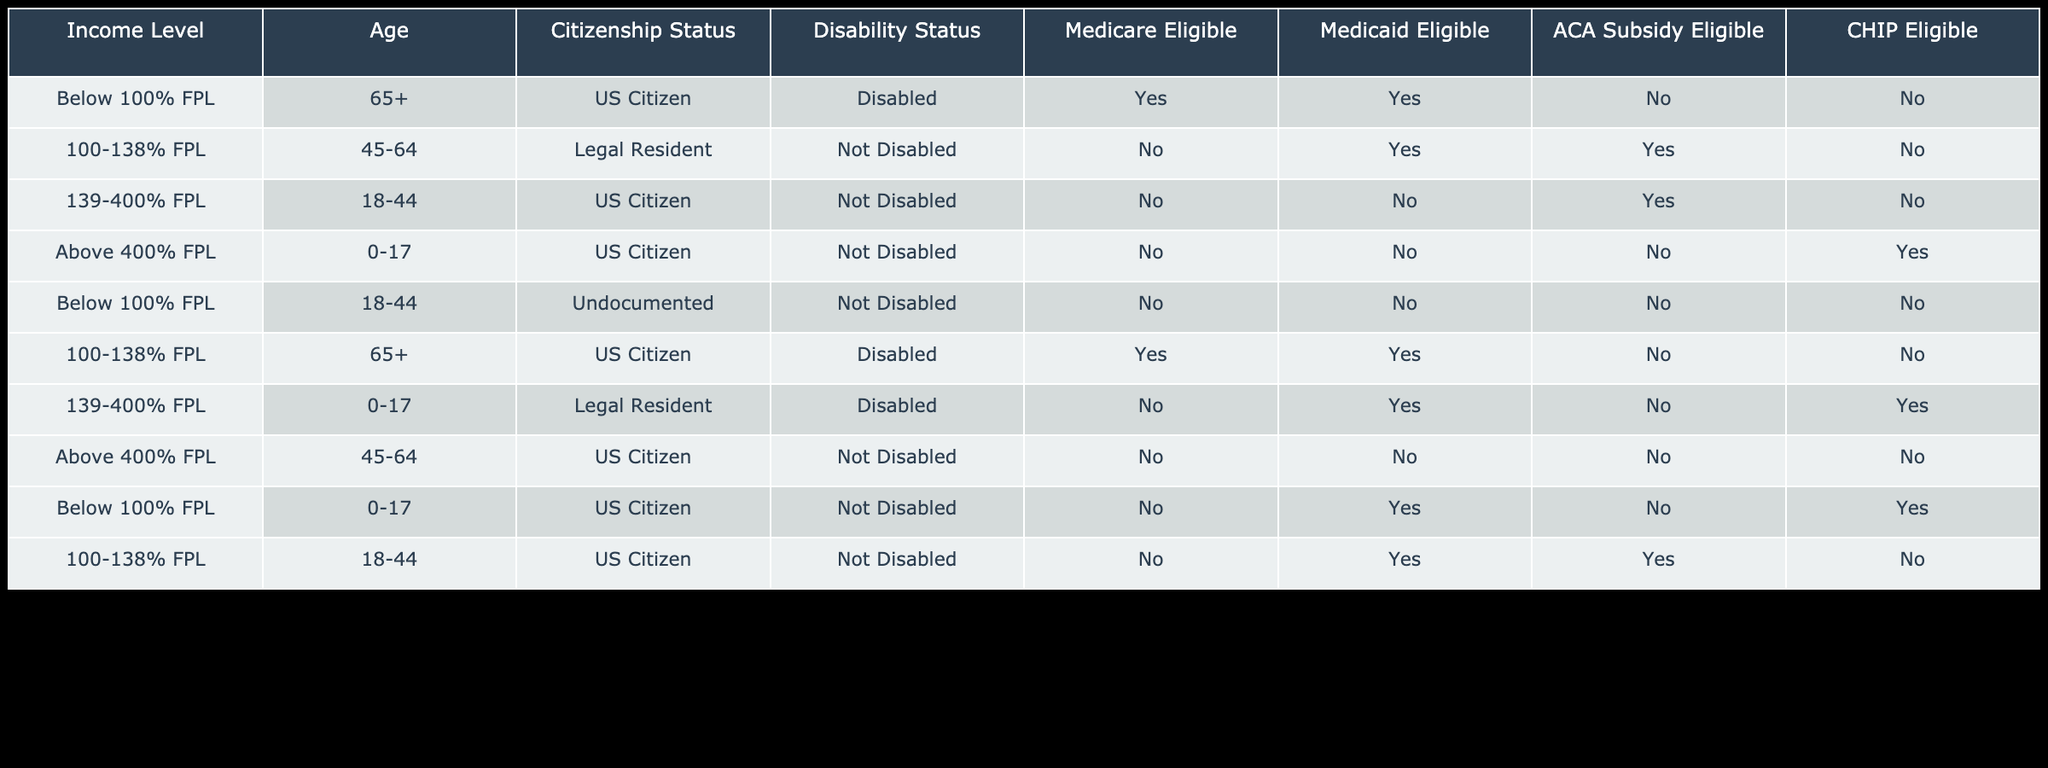What is the citizenship status of individuals eligible for Medicaid in the income range of 100-138% FPL? In the table, there are two rows with the income range of 100-138% FPL. Both individuals in this income group are noted as either a "US Citizen" or "Legal Resident." However, since we are specifically looking for Medicaid eligibility, we see that both entries (one for age 45-64 and one for age 65+) have "US Citizen" as the citizenship status.
Answer: US Citizen How many individuals aged 0-17 are eligible for CHIP? In the table, we find two rows corresponding to individuals aged 0-17. One is from a category of "Above 400% FPL," which is eligible, and the other is from a category of "Below 100% FPL," which also states eligibility. Therefore, we can count a total of two individuals in this group.
Answer: 2 Is it true that individuals aged 65 and over, who are disabled, are eligible for Medicare? By consulting the rows of the table that mention individuals aged 65+, we can see that both records for this age group and disability status indicate they are eligible for Medicare, confirming that individuals aged 65 and over who are disabled are indeed eligible.
Answer: Yes What is the total number of individuals eligible for ACA subsidies across all income levels? To determine this, we need to look for the "ACA Subsidy Eligible" column and count the "Yes" responses. Only two individuals qualify for ACA subsidies out of the ten rows provided in the table. Specifically, those between the income levels of 100-138% FPL and 139-400% FPL show eligibility.
Answer: 2 Which income level has individuals aged 18-44 that are eligible for Medicaid? In the rows for individuals aged 18-44, only the income range of 100-138% FPL shows eligibility for Medicaid. While others in higher income categories are not eligible, this specific income range has "Yes" for Medicaid eligibility, making it the only filled response for this age group regarding Medicaid.
Answer: 100-138% FPL Are there any undocumented individuals eligible for any healthcare subsidies? When reviewing the table, it can be seen that the entry for the individual classified as undocumented at an income level below 100% FPL does not show eligibility for any subsidies, leaving us to conclude that there are no undocumented individuals eligible for any form of healthcare assistance reflected in this data.
Answer: No What percentage of individuals under 18 are eligible for Medicaid based on the table? There are four individuals aged 0-17 listed in two rows: one shows eligibility for Medicaid (the row below 100% FPL), while another row at 139-400% FPL shows the same. Thus, two out of four individuals leads to an eligibility calculation of 2/4 × 100 = 50%.
Answer: 50% What is the age range of individuals who are eligible for Medicare? Looking at the relevant column for Medicare eligibility, we find that only those over 65 years and those listed as 65+ who are disabled are eligible, confirming that only individuals aged 65 or above meet the conditions necessary for qualifying for Medicare assistance.
Answer: 65+ 